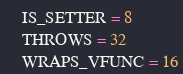Convert code to text. <code><loc_0><loc_0><loc_500><loc_500><_Python_>    IS_SETTER = 8
    THROWS = 32
    WRAPS_VFUNC = 16


</code> 